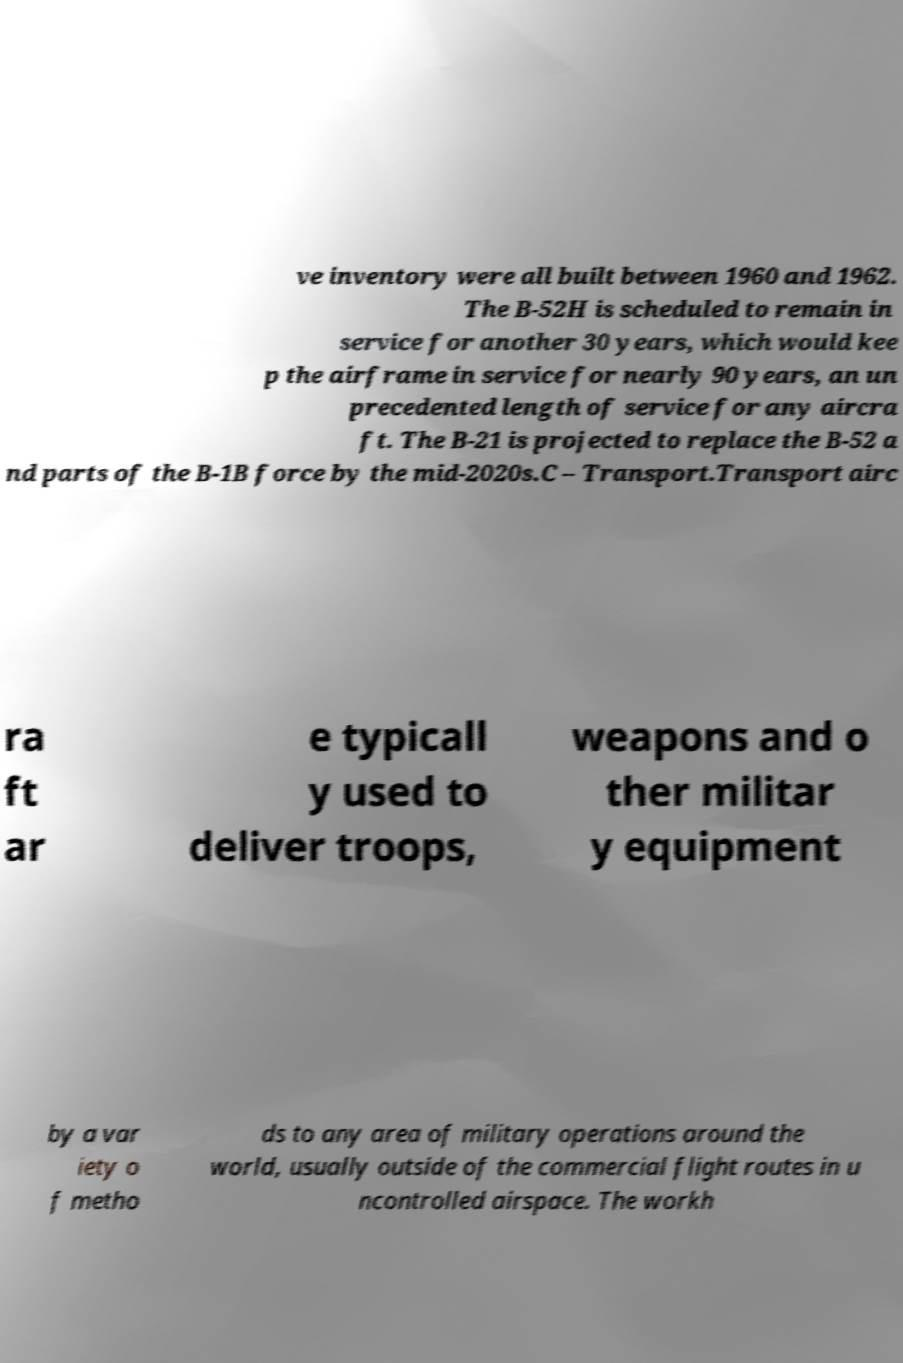Can you read and provide the text displayed in the image?This photo seems to have some interesting text. Can you extract and type it out for me? ve inventory were all built between 1960 and 1962. The B-52H is scheduled to remain in service for another 30 years, which would kee p the airframe in service for nearly 90 years, an un precedented length of service for any aircra ft. The B-21 is projected to replace the B-52 a nd parts of the B-1B force by the mid-2020s.C – Transport.Transport airc ra ft ar e typicall y used to deliver troops, weapons and o ther militar y equipment by a var iety o f metho ds to any area of military operations around the world, usually outside of the commercial flight routes in u ncontrolled airspace. The workh 